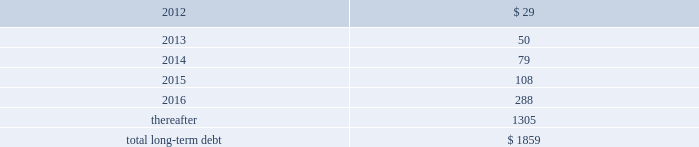Performance of the company 2019s obligations under the senior notes , including any repurchase obligations resulting from a change of control , is unconditionally guaranteed , jointly and severally , on an unsecured basis , by each of hii 2019s existing and future domestic restricted subsidiaries that guarantees debt under the credit facility ( the 201csubsidiary guarantors 201d ) .
The guarantees rank equally with all other unsecured and unsubordinated indebtedness of the guarantors .
The subsidiary guarantors are each directly or indirectly 100% ( 100 % ) owned by hii .
There are no significant restrictions on the ability of hii or any subsidiary guarantor to obtain funds from their respective subsidiaries by dividend or loan .
Mississippi economic development revenue bonds 2014as of december 31 , 2011 and 2010 , the company had $ 83.7 million outstanding from the issuance of industrial revenue bonds issued by the mississippi business finance corporation .
These bonds accrue interest at a fixed rate of 7.81% ( 7.81 % ) per annum ( payable semi-annually ) and mature in 2024 .
While repayment of principal and interest is guaranteed by northrop grumman systems corporation , hii has agreed to indemnify northrop grumman systems corporation for any losses related to the guaranty .
In accordance with the terms of the bonds , the proceeds have been used to finance the construction , reconstruction , and renovation of the company 2019s interest in certain ship manufacturing and repair facilities , or portions thereof , located in the state of mississippi .
Gulf opportunity zone industrial development revenue bonds 2014as of december 31 , 2011 and 2010 , the company had $ 21.6 million outstanding from the issuance of gulf opportunity zone industrial development revenue bonds ( 201cgo zone irbs 201d ) issued by the mississippi business finance corporation .
The go zone irbs were initially issued in a principal amount of $ 200 million , and in november 2010 , in connection with the anticipated spin-off , hii purchased $ 178 million of the bonds using the proceeds from a $ 178 million intercompany loan from northrop grumman .
See note 20 : related party transactions and former parent company equity .
The remaining bonds accrue interest at a fixed rate of 4.55% ( 4.55 % ) per annum ( payable semi-annually ) , and mature in 2028 .
In accordance with the terms of the bonds , the proceeds have been used to finance the construction , reconstruction , and renovation of the company 2019s interest in certain ship manufacturing and repair facilities , or portions thereof , located in the state of mississippi .
The estimated fair value of the company 2019s total long-term debt , including current portions , at december 31 , 2011 and 2010 , was $ 1864 million and $ 128 million , respectively .
The fair value of the total long-term debt was calculated based on recent trades for most of the company 2019s debt instruments or based on interest rates prevailing on debt with substantially similar risks , terms and maturities .
The aggregate amounts of principal payments due on long-term debt for each of the next five years and thereafter are : ( $ in millions ) .
14 .
Investigations , claims , and litigation the company is involved in legal proceedings before various courts and administrative agencies , and is periodically subject to government examinations , inquiries and investigations .
Pursuant to fasb accounting standard codification 450 contingencies , the company has accrued for losses associated with investigations , claims and litigation when , and to the extent that , loss amounts related to the investigations , claims and litigation are probable and can be reasonably estimated .
The actual losses that might be incurred to resolve such investigations , claims and litigation may be higher or lower than the amounts accrued .
For matters where a material loss is probable or reasonably possible and the amount of loss cannot be reasonably estimated , but the company is able to reasonably estimate a range of possible losses , such estimated range is required to be disclosed in these notes .
This estimated range would be based on information currently available to the company and would involve elements of judgment and significant uncertainties .
This estimated range of possible loss would not represent the company 2019s maximum possible loss exposure .
For matters as to which the company is not able to reasonably estimate a possible loss or range of loss , the company is required to indicate the reasons why it is unable to estimate the possible loss or range of loss .
For matters not specifically described in these notes , the company does not believe , based on information currently available to it , that it is reasonably possible that the liabilities , if any , arising from .
What is the amount of interest payment incurred from the bonds issued by the mississippi business finance corporation? 
Computations: ((83.7 * 7.81%) / 2)
Answer: 3.26849. Performance of the company 2019s obligations under the senior notes , including any repurchase obligations resulting from a change of control , is unconditionally guaranteed , jointly and severally , on an unsecured basis , by each of hii 2019s existing and future domestic restricted subsidiaries that guarantees debt under the credit facility ( the 201csubsidiary guarantors 201d ) .
The guarantees rank equally with all other unsecured and unsubordinated indebtedness of the guarantors .
The subsidiary guarantors are each directly or indirectly 100% ( 100 % ) owned by hii .
There are no significant restrictions on the ability of hii or any subsidiary guarantor to obtain funds from their respective subsidiaries by dividend or loan .
Mississippi economic development revenue bonds 2014as of december 31 , 2011 and 2010 , the company had $ 83.7 million outstanding from the issuance of industrial revenue bonds issued by the mississippi business finance corporation .
These bonds accrue interest at a fixed rate of 7.81% ( 7.81 % ) per annum ( payable semi-annually ) and mature in 2024 .
While repayment of principal and interest is guaranteed by northrop grumman systems corporation , hii has agreed to indemnify northrop grumman systems corporation for any losses related to the guaranty .
In accordance with the terms of the bonds , the proceeds have been used to finance the construction , reconstruction , and renovation of the company 2019s interest in certain ship manufacturing and repair facilities , or portions thereof , located in the state of mississippi .
Gulf opportunity zone industrial development revenue bonds 2014as of december 31 , 2011 and 2010 , the company had $ 21.6 million outstanding from the issuance of gulf opportunity zone industrial development revenue bonds ( 201cgo zone irbs 201d ) issued by the mississippi business finance corporation .
The go zone irbs were initially issued in a principal amount of $ 200 million , and in november 2010 , in connection with the anticipated spin-off , hii purchased $ 178 million of the bonds using the proceeds from a $ 178 million intercompany loan from northrop grumman .
See note 20 : related party transactions and former parent company equity .
The remaining bonds accrue interest at a fixed rate of 4.55% ( 4.55 % ) per annum ( payable semi-annually ) , and mature in 2028 .
In accordance with the terms of the bonds , the proceeds have been used to finance the construction , reconstruction , and renovation of the company 2019s interest in certain ship manufacturing and repair facilities , or portions thereof , located in the state of mississippi .
The estimated fair value of the company 2019s total long-term debt , including current portions , at december 31 , 2011 and 2010 , was $ 1864 million and $ 128 million , respectively .
The fair value of the total long-term debt was calculated based on recent trades for most of the company 2019s debt instruments or based on interest rates prevailing on debt with substantially similar risks , terms and maturities .
The aggregate amounts of principal payments due on long-term debt for each of the next five years and thereafter are : ( $ in millions ) .
14 .
Investigations , claims , and litigation the company is involved in legal proceedings before various courts and administrative agencies , and is periodically subject to government examinations , inquiries and investigations .
Pursuant to fasb accounting standard codification 450 contingencies , the company has accrued for losses associated with investigations , claims and litigation when , and to the extent that , loss amounts related to the investigations , claims and litigation are probable and can be reasonably estimated .
The actual losses that might be incurred to resolve such investigations , claims and litigation may be higher or lower than the amounts accrued .
For matters where a material loss is probable or reasonably possible and the amount of loss cannot be reasonably estimated , but the company is able to reasonably estimate a range of possible losses , such estimated range is required to be disclosed in these notes .
This estimated range would be based on information currently available to the company and would involve elements of judgment and significant uncertainties .
This estimated range of possible loss would not represent the company 2019s maximum possible loss exposure .
For matters as to which the company is not able to reasonably estimate a possible loss or range of loss , the company is required to indicate the reasons why it is unable to estimate the possible loss or range of loss .
For matters not specifically described in these notes , the company does not believe , based on information currently available to it , that it is reasonably possible that the liabilities , if any , arising from .
How is the cash flow statement from financing activities affected by the change in the balance of the long-term debt from 2010 to 2011? 
Computations: (1864 - 128)
Answer: 1736.0. 